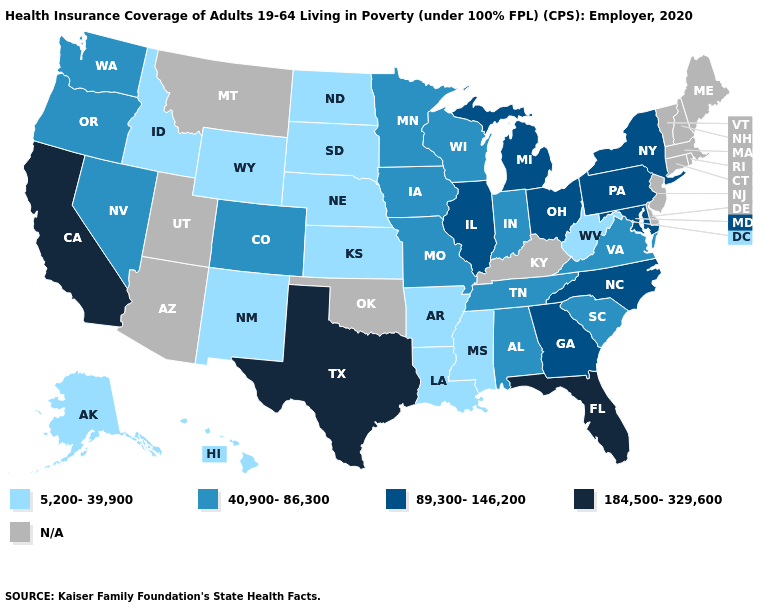Name the states that have a value in the range 40,900-86,300?
Short answer required. Alabama, Colorado, Indiana, Iowa, Minnesota, Missouri, Nevada, Oregon, South Carolina, Tennessee, Virginia, Washington, Wisconsin. Name the states that have a value in the range 40,900-86,300?
Give a very brief answer. Alabama, Colorado, Indiana, Iowa, Minnesota, Missouri, Nevada, Oregon, South Carolina, Tennessee, Virginia, Washington, Wisconsin. Name the states that have a value in the range 40,900-86,300?
Answer briefly. Alabama, Colorado, Indiana, Iowa, Minnesota, Missouri, Nevada, Oregon, South Carolina, Tennessee, Virginia, Washington, Wisconsin. Which states have the highest value in the USA?
Concise answer only. California, Florida, Texas. Which states have the highest value in the USA?
Give a very brief answer. California, Florida, Texas. What is the highest value in the South ?
Concise answer only. 184,500-329,600. What is the value of New York?
Write a very short answer. 89,300-146,200. What is the value of Texas?
Quick response, please. 184,500-329,600. Name the states that have a value in the range 184,500-329,600?
Write a very short answer. California, Florida, Texas. What is the value of New Mexico?
Short answer required. 5,200-39,900. What is the value of Mississippi?
Concise answer only. 5,200-39,900. Name the states that have a value in the range 40,900-86,300?
Quick response, please. Alabama, Colorado, Indiana, Iowa, Minnesota, Missouri, Nevada, Oregon, South Carolina, Tennessee, Virginia, Washington, Wisconsin. Does the first symbol in the legend represent the smallest category?
Answer briefly. Yes. 